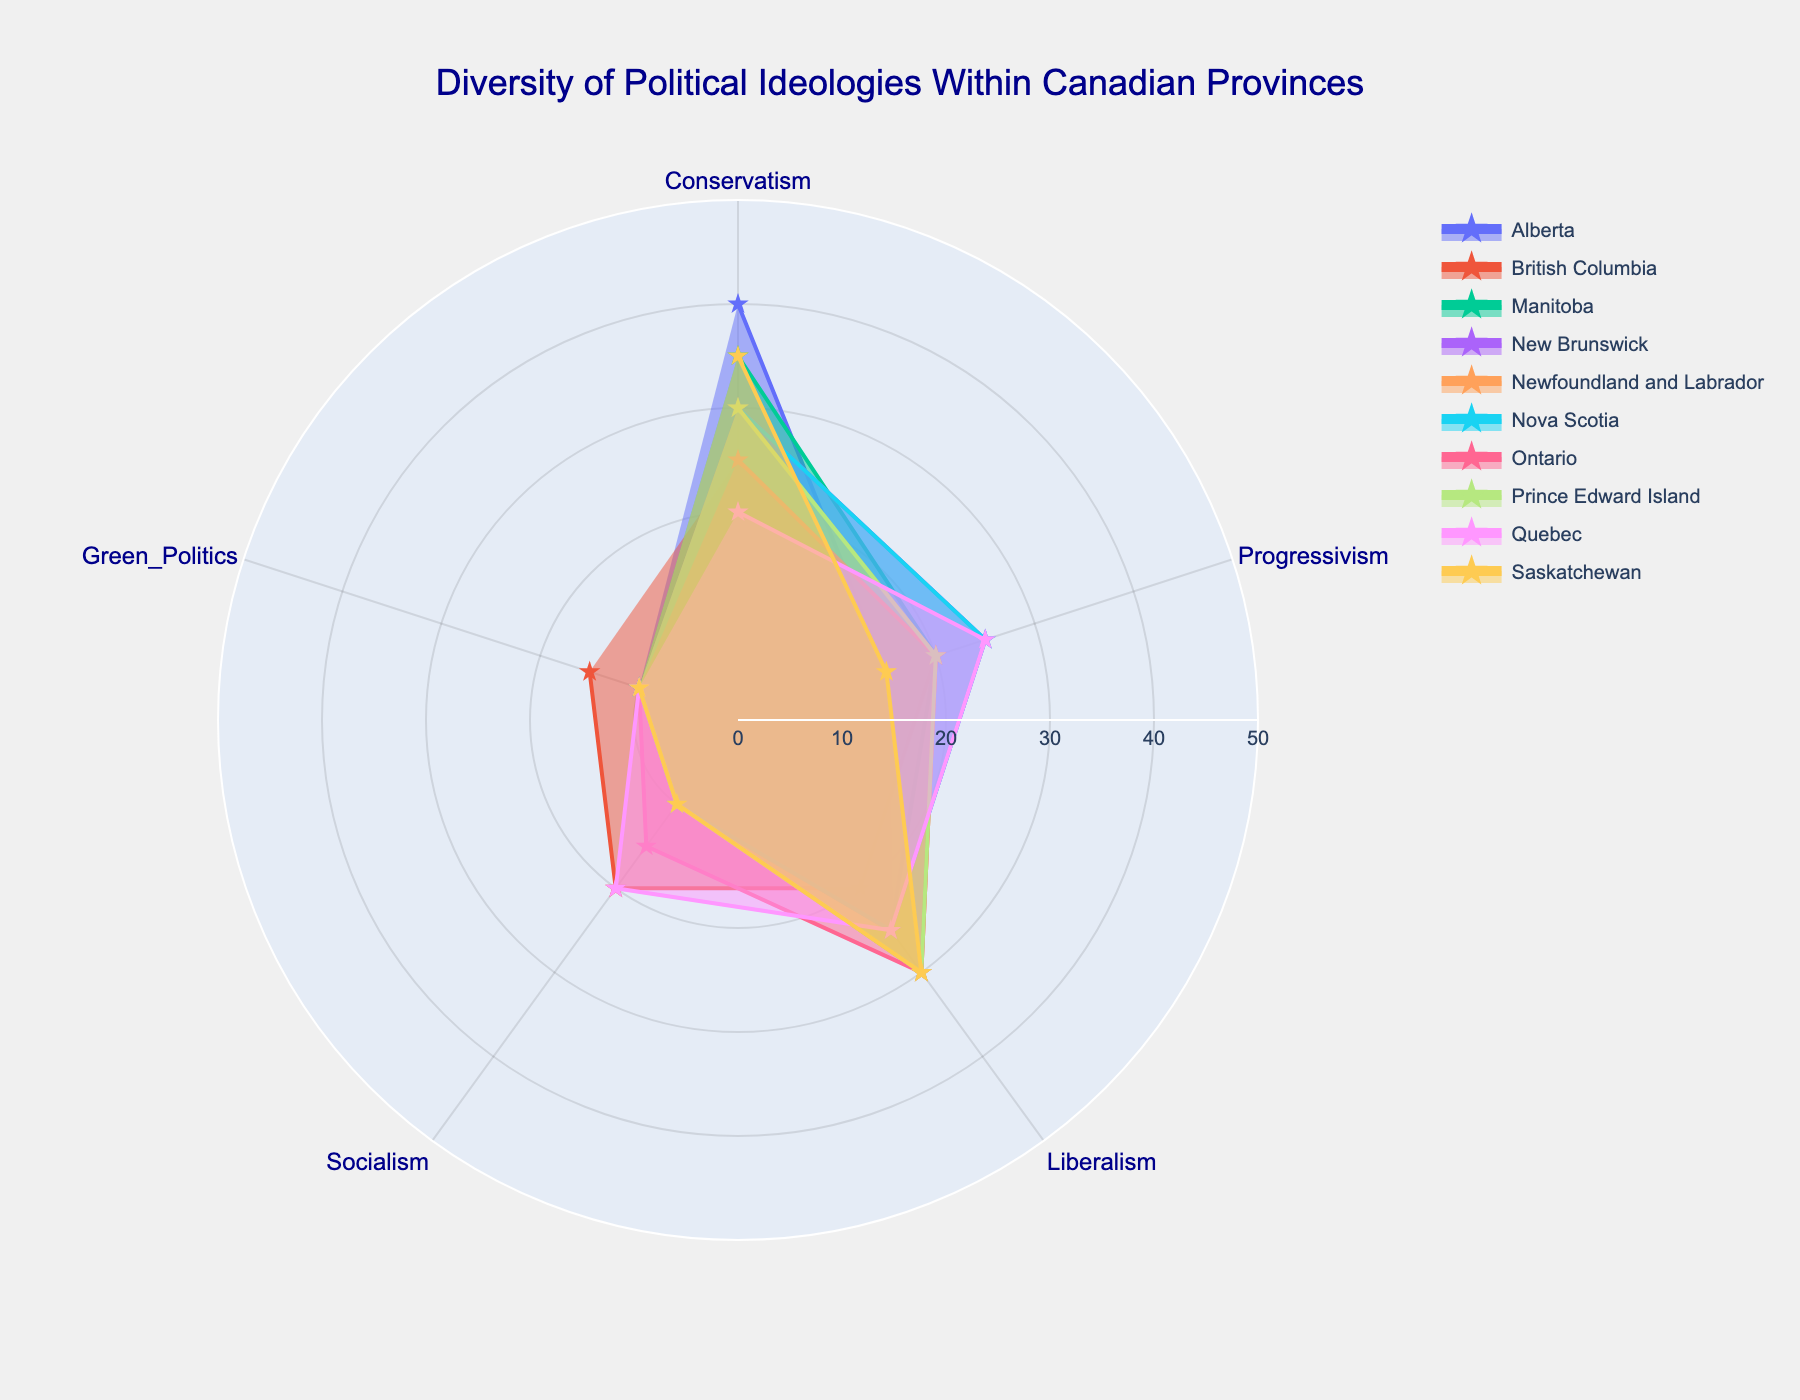What is the title of the chart? The title is located at the top of the chart and it describes what the chart is about. The title reads 'Diversity of Political Ideologies Within Canadian Provinces'.
Answer: Diversity of Political Ideologies Within Canadian Provinces Which province has the highest percentage of conservatism? By looking at the "Conservatism" values for all provinces, Alberta has the highest percentage with a value of 40.
Answer: Alberta How many provinces have a 25% or higher value for Liberalism? By examining the values for "Liberalism" in each province, Alberta, Manitoba, New Brunswick, Newfoundland and Labrador, Nova Scotia, Ontario, Prince Edward Island, and Saskatchewan all have 25% or higher.
Answer: 8 Which political ideology has the highest value in British Columbia? By examining the values for all political ideologies in British Columbia, the highest value is for Socialism, which is 20.
Answer: Socialism What is the average percentage value for Green Politics across all provinces? Sum all values for "Green Politics" across provinces and then divide by the number of provinces: (10+15+10+10+10+10+10+10+10+10) / 10 = 10.5
Answer: 10.5 Compare the percentage of Progressivism in Quebec and Ontario and state which one is higher. From the chart, Quebec has a value of 25 for "Progressivism" while Ontario has a value of 20. Therefore, Quebec's percentage is higher.
Answer: Quebec Which province shows an equal percentage for Conservatism and Liberalism? By checking the values for both "Conservatism" and "Liberalism" within each province, Saskatchewan has the same value (35) for both.
Answer: Saskatchewan What is the difference in the percentage of Conservatism between Alberta and Quebec? Alberta has 40% for "Conservatism" and Quebec has 20%. The difference is calculated by 40 - 20 = 20.
Answer: 20 Which political ideology ranges between 10-20% for more than 3 provinces? "Progressivism" ranges between 10-20% for Alberta, British Columbia, Manitoba, Newfoundland and Labrador, Ontario, and Prince Edward Island, which is more than 3 provinces.
Answer: Progressivism What is the total value of Socialism percentages across all provinces? By adding up all "Socialism" values across each province (10+20+10+10+10+10+15+10+20+10), the total value is 125.
Answer: 125 